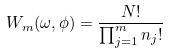Convert formula to latex. <formula><loc_0><loc_0><loc_500><loc_500>W _ { m } ( \omega , \phi ) = \frac { N ! } { \prod _ { j = 1 } ^ { m } n _ { j } ! }</formula> 